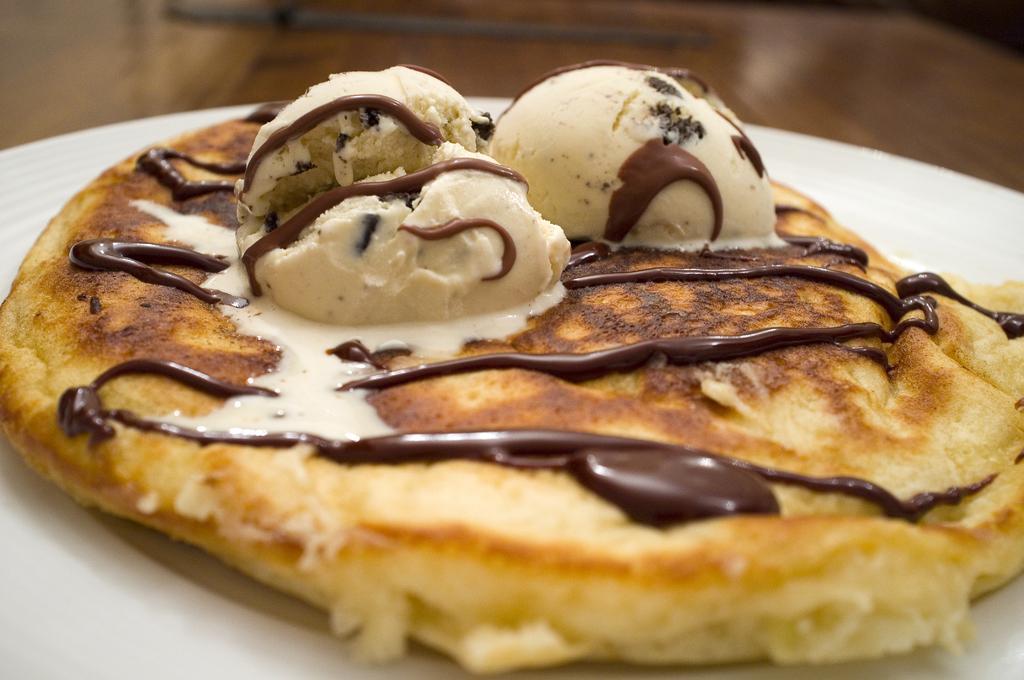Please provide a concise description of this image. We can see plate with food on the wooden platform. 